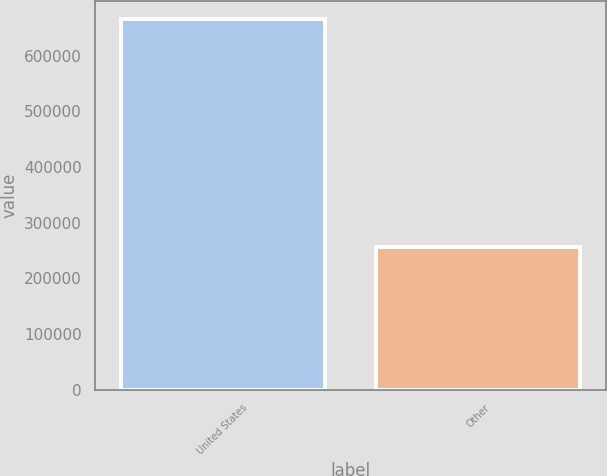Convert chart to OTSL. <chart><loc_0><loc_0><loc_500><loc_500><bar_chart><fcel>United States<fcel>Other<nl><fcel>665219<fcel>256237<nl></chart> 